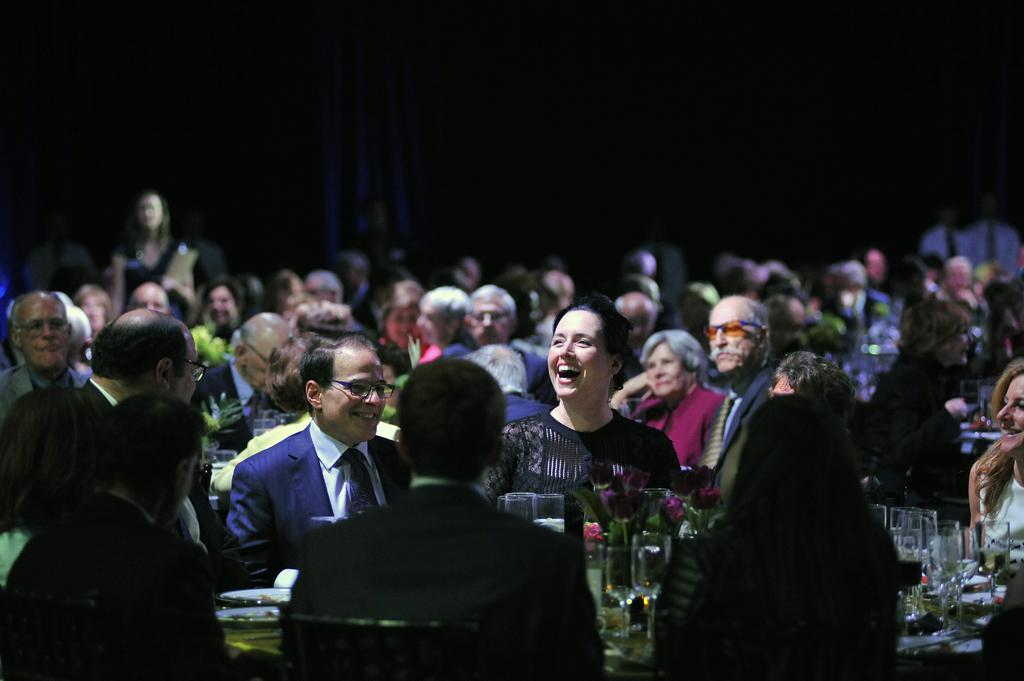What is the main subject of the image? The main subject of the image is a group of people. What objects can be seen in the image besides the people? There are glasses and flowers in the image, as well as other objects. Can you describe the background of the image? The background of the image is dark. What type of metal can be seen in the image? There is no metal present in the image. Is there a band playing in the image? There is no band present in the image. 